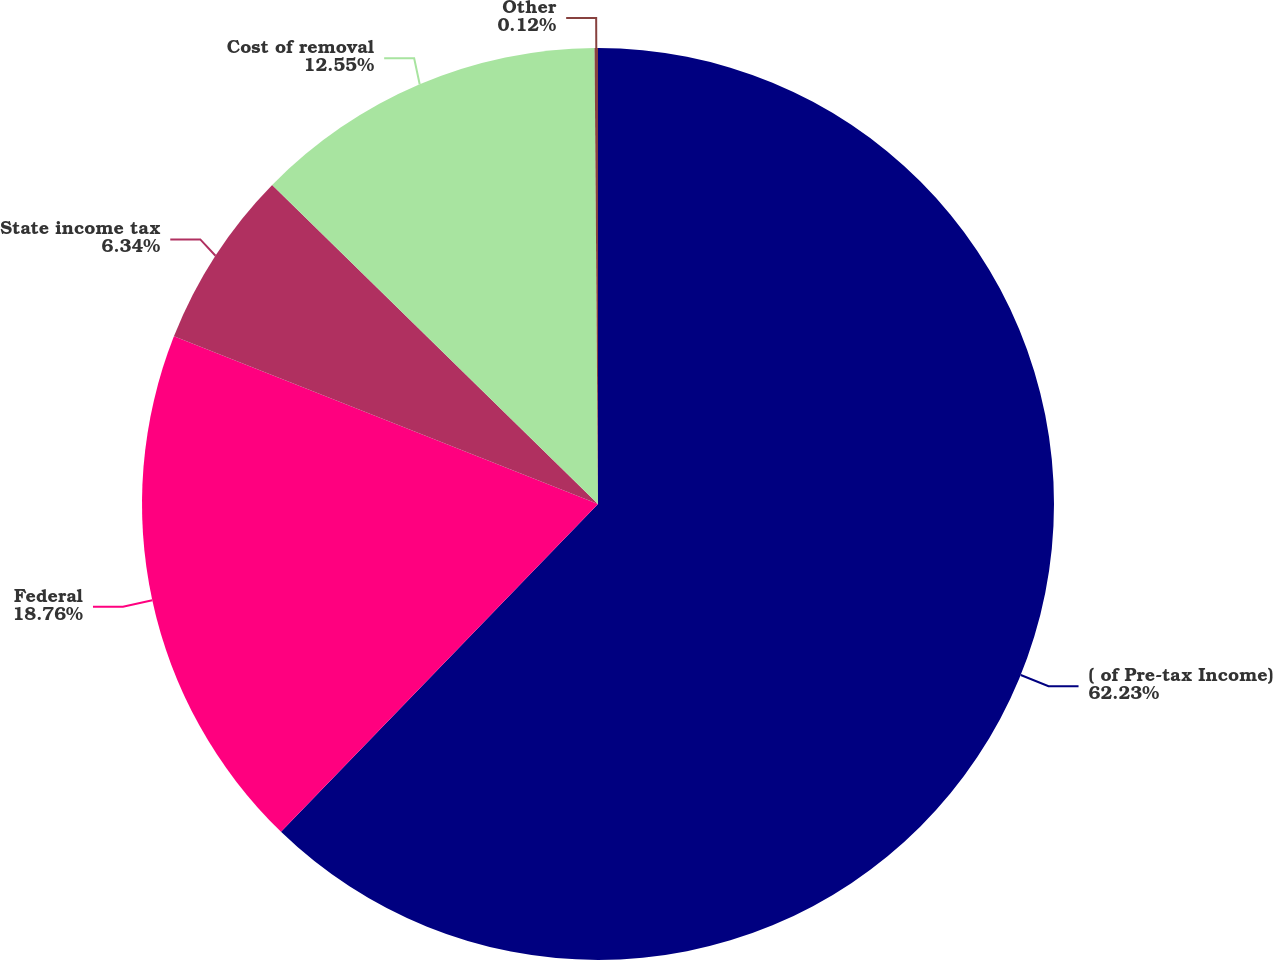Convert chart to OTSL. <chart><loc_0><loc_0><loc_500><loc_500><pie_chart><fcel>( of Pre-tax Income)<fcel>Federal<fcel>State income tax<fcel>Cost of removal<fcel>Other<nl><fcel>62.24%<fcel>18.76%<fcel>6.34%<fcel>12.55%<fcel>0.12%<nl></chart> 